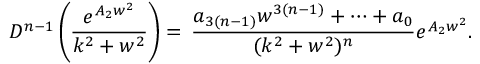<formula> <loc_0><loc_0><loc_500><loc_500>D ^ { n - 1 } \left ( \frac { e ^ { A _ { 2 } w ^ { 2 } } } { k ^ { 2 } + w ^ { 2 } } \right ) = \, \frac { a _ { 3 ( n - 1 ) } w ^ { 3 ( n - 1 ) } + \dots + a _ { 0 } } { ( k ^ { 2 } + w ^ { 2 } ) ^ { n } } e ^ { A _ { 2 } w ^ { 2 } } .</formula> 